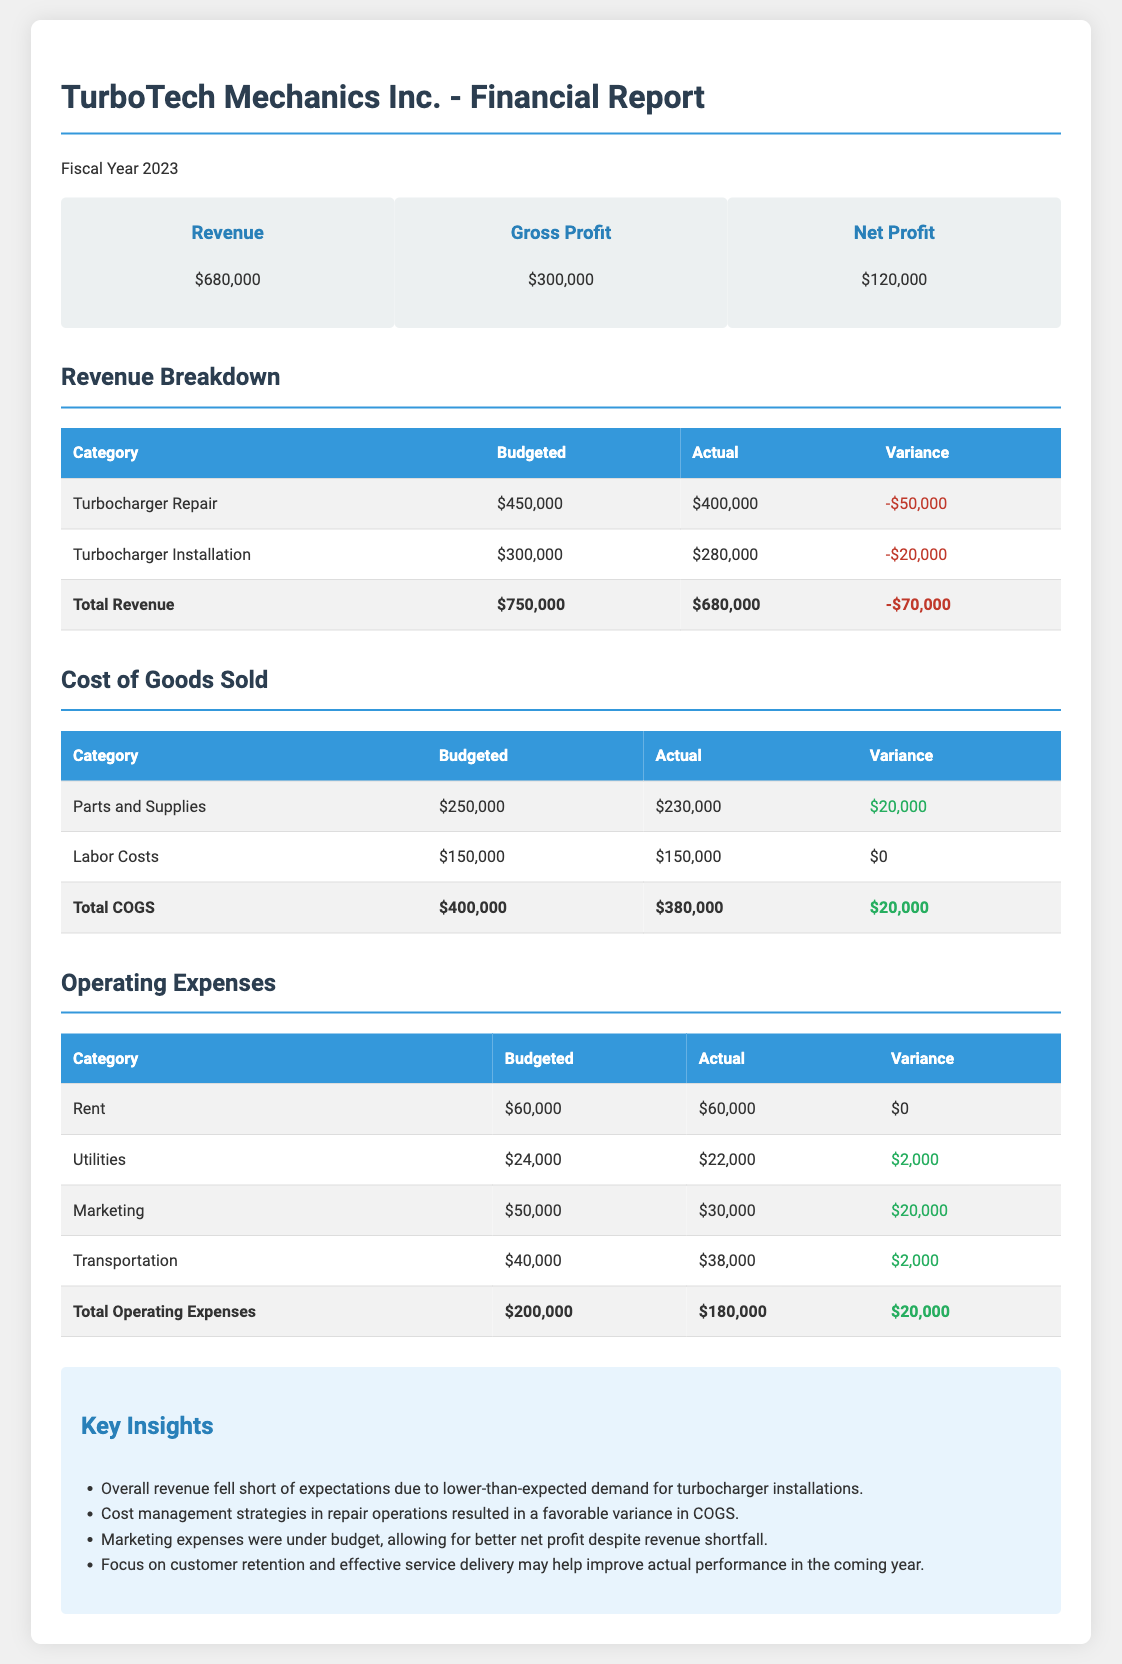What was the budgeted revenue for turbocharger repair? The document states the budgeted revenue for turbocharger repair is $450,000.
Answer: $450,000 What was the actual net profit for the fiscal year? The actual net profit for the fiscal year is mentioned in the financial summary as $120,000.
Answer: $120,000 What is the variance for turbocharger installation revenue? The variance for turbocharger installation revenue is calculated as the difference between budgeted and actual amounts, which is -$20,000.
Answer: -$20,000 What was the total cost of goods sold? The total cost of goods sold is listed as $380,000 in the COGS section.
Answer: $380,000 Which category has the highest variance in revenue? The turbocharger repair category shows the highest negative variance of -$50,000.
Answer: Turbocharger Repair How much did TurboTech spend on labor costs? The actual labor costs amount to $150,000, as noted in the COGS section.
Answer: $150,000 What was the total for marketing expenses? The total marketing expenses incurred were $30,000 according to the operating expenses table.
Answer: $30,000 What is the positive variance in parts and supplies costs? The variance in parts and supplies costs is positive by $20,000, indicating lower actual expenses than budgeted.
Answer: $20,000 What is one key insight from the report? The report emphasizes that overall revenue fell short due to lower-than-expected demand for installations.
Answer: Lower-than-expected demand for installations 